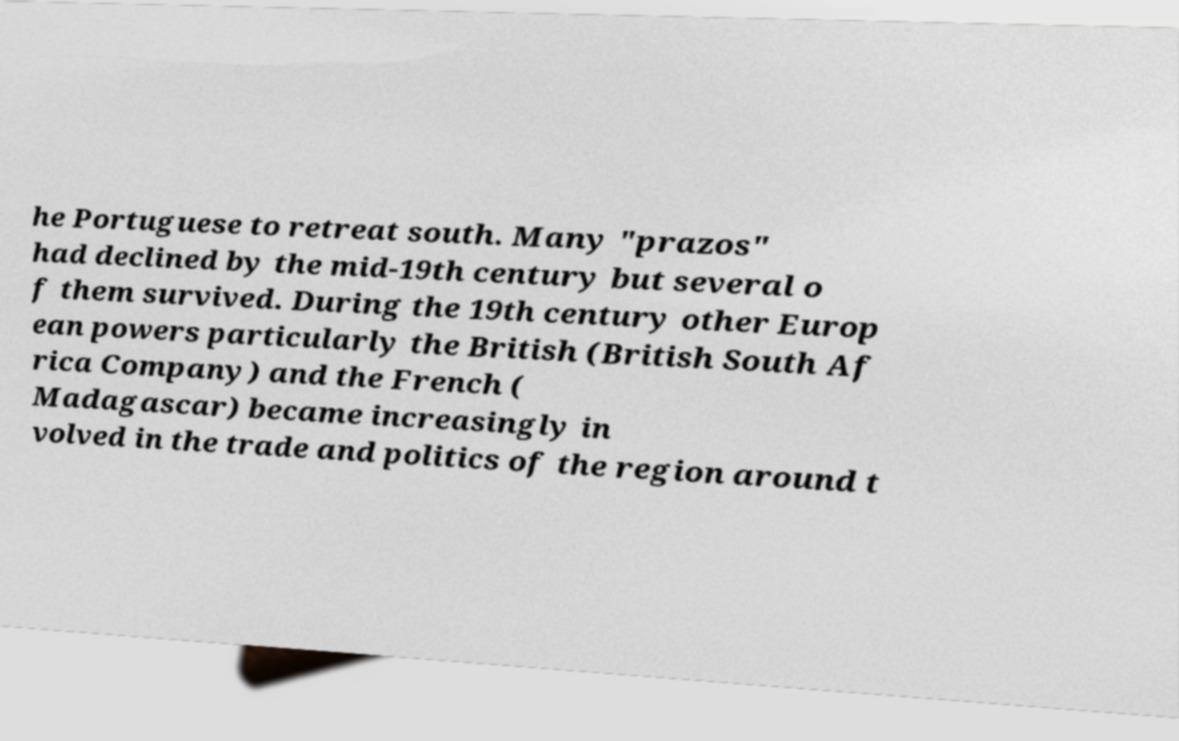For documentation purposes, I need the text within this image transcribed. Could you provide that? he Portuguese to retreat south. Many "prazos" had declined by the mid-19th century but several o f them survived. During the 19th century other Europ ean powers particularly the British (British South Af rica Company) and the French ( Madagascar) became increasingly in volved in the trade and politics of the region around t 